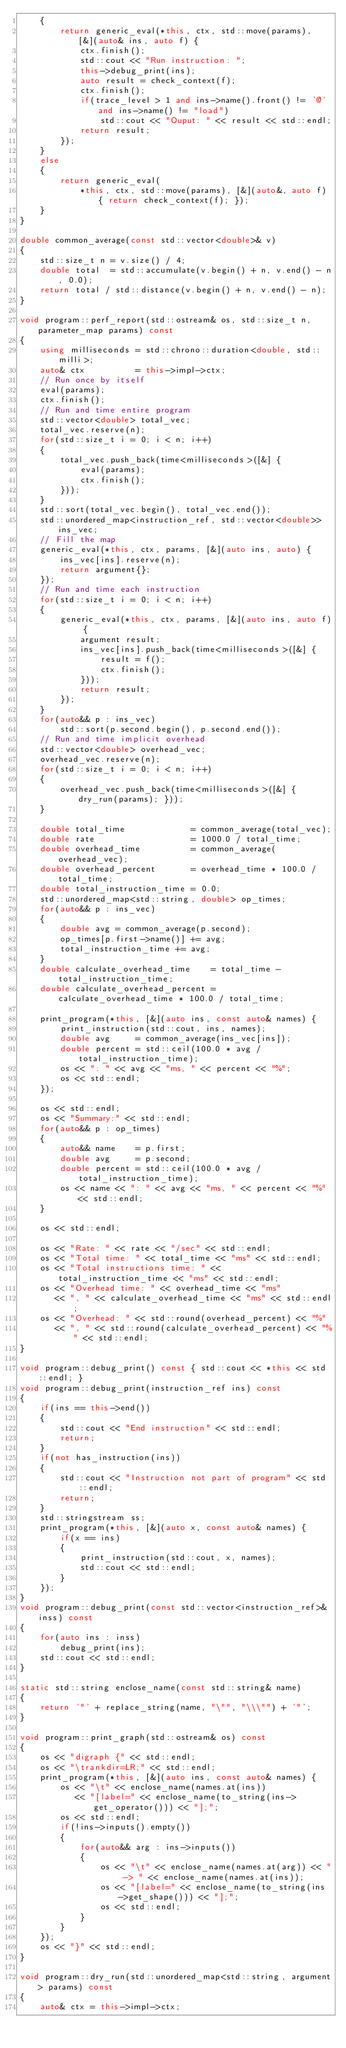Convert code to text. <code><loc_0><loc_0><loc_500><loc_500><_C++_>    {
        return generic_eval(*this, ctx, std::move(params), [&](auto& ins, auto f) {
            ctx.finish();
            std::cout << "Run instruction: ";
            this->debug_print(ins);
            auto result = check_context(f);
            ctx.finish();
            if(trace_level > 1 and ins->name().front() != '@' and ins->name() != "load")
                std::cout << "Ouput: " << result << std::endl;
            return result;
        });
    }
    else
    {
        return generic_eval(
            *this, ctx, std::move(params), [&](auto&, auto f) { return check_context(f); });
    }
}

double common_average(const std::vector<double>& v)
{
    std::size_t n = v.size() / 4;
    double total  = std::accumulate(v.begin() + n, v.end() - n, 0.0);
    return total / std::distance(v.begin() + n, v.end() - n);
}

void program::perf_report(std::ostream& os, std::size_t n, parameter_map params) const
{
    using milliseconds = std::chrono::duration<double, std::milli>;
    auto& ctx          = this->impl->ctx;
    // Run once by itself
    eval(params);
    ctx.finish();
    // Run and time entire program
    std::vector<double> total_vec;
    total_vec.reserve(n);
    for(std::size_t i = 0; i < n; i++)
    {
        total_vec.push_back(time<milliseconds>([&] {
            eval(params);
            ctx.finish();
        }));
    }
    std::sort(total_vec.begin(), total_vec.end());
    std::unordered_map<instruction_ref, std::vector<double>> ins_vec;
    // Fill the map
    generic_eval(*this, ctx, params, [&](auto ins, auto) {
        ins_vec[ins].reserve(n);
        return argument{};
    });
    // Run and time each instruction
    for(std::size_t i = 0; i < n; i++)
    {
        generic_eval(*this, ctx, params, [&](auto ins, auto f) {
            argument result;
            ins_vec[ins].push_back(time<milliseconds>([&] {
                result = f();
                ctx.finish();
            }));
            return result;
        });
    }
    for(auto&& p : ins_vec)
        std::sort(p.second.begin(), p.second.end());
    // Run and time implicit overhead
    std::vector<double> overhead_vec;
    overhead_vec.reserve(n);
    for(std::size_t i = 0; i < n; i++)
    {
        overhead_vec.push_back(time<milliseconds>([&] { dry_run(params); }));
    }

    double total_time             = common_average(total_vec);
    double rate                   = 1000.0 / total_time;
    double overhead_time          = common_average(overhead_vec);
    double overhead_percent       = overhead_time * 100.0 / total_time;
    double total_instruction_time = 0.0;
    std::unordered_map<std::string, double> op_times;
    for(auto&& p : ins_vec)
    {
        double avg = common_average(p.second);
        op_times[p.first->name()] += avg;
        total_instruction_time += avg;
    }
    double calculate_overhead_time    = total_time - total_instruction_time;
    double calculate_overhead_percent = calculate_overhead_time * 100.0 / total_time;

    print_program(*this, [&](auto ins, const auto& names) {
        print_instruction(std::cout, ins, names);
        double avg     = common_average(ins_vec[ins]);
        double percent = std::ceil(100.0 * avg / total_instruction_time);
        os << ": " << avg << "ms, " << percent << "%";
        os << std::endl;
    });

    os << std::endl;
    os << "Summary:" << std::endl;
    for(auto&& p : op_times)
    {
        auto&& name    = p.first;
        double avg     = p.second;
        double percent = std::ceil(100.0 * avg / total_instruction_time);
        os << name << ": " << avg << "ms, " << percent << "%" << std::endl;
    }

    os << std::endl;

    os << "Rate: " << rate << "/sec" << std::endl;
    os << "Total time: " << total_time << "ms" << std::endl;
    os << "Total instructions time: " << total_instruction_time << "ms" << std::endl;
    os << "Overhead time: " << overhead_time << "ms"
       << ", " << calculate_overhead_time << "ms" << std::endl;
    os << "Overhead: " << std::round(overhead_percent) << "%"
       << ", " << std::round(calculate_overhead_percent) << "%" << std::endl;
}

void program::debug_print() const { std::cout << *this << std::endl; }
void program::debug_print(instruction_ref ins) const
{
    if(ins == this->end())
    {
        std::cout << "End instruction" << std::endl;
        return;
    }
    if(not has_instruction(ins))
    {
        std::cout << "Instruction not part of program" << std::endl;
        return;
    }
    std::stringstream ss;
    print_program(*this, [&](auto x, const auto& names) {
        if(x == ins)
        {
            print_instruction(std::cout, x, names);
            std::cout << std::endl;
        }
    });
}
void program::debug_print(const std::vector<instruction_ref>& inss) const
{
    for(auto ins : inss)
        debug_print(ins);
    std::cout << std::endl;
}

static std::string enclose_name(const std::string& name)
{
    return '"' + replace_string(name, "\"", "\\\"") + '"';
}

void program::print_graph(std::ostream& os) const
{
    os << "digraph {" << std::endl;
    os << "\trankdir=LR;" << std::endl;
    print_program(*this, [&](auto ins, const auto& names) {
        os << "\t" << enclose_name(names.at(ins))
           << "[label=" << enclose_name(to_string(ins->get_operator())) << "];";
        os << std::endl;
        if(!ins->inputs().empty())
        {
            for(auto&& arg : ins->inputs())
            {
                os << "\t" << enclose_name(names.at(arg)) << " -> " << enclose_name(names.at(ins));
                os << "[label=" << enclose_name(to_string(ins->get_shape())) << "];";
                os << std::endl;
            }
        }
    });
    os << "}" << std::endl;
}

void program::dry_run(std::unordered_map<std::string, argument> params) const
{
    auto& ctx = this->impl->ctx;</code> 